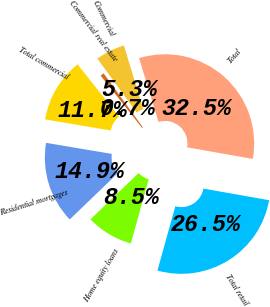Convert chart to OTSL. <chart><loc_0><loc_0><loc_500><loc_500><pie_chart><fcel>Commercial<fcel>Commercial real estate<fcel>Total commercial<fcel>Residential mortgages<fcel>Home equity loans<fcel>Total retail<fcel>Total<nl><fcel>5.31%<fcel>0.66%<fcel>11.67%<fcel>14.85%<fcel>8.49%<fcel>26.53%<fcel>32.49%<nl></chart> 